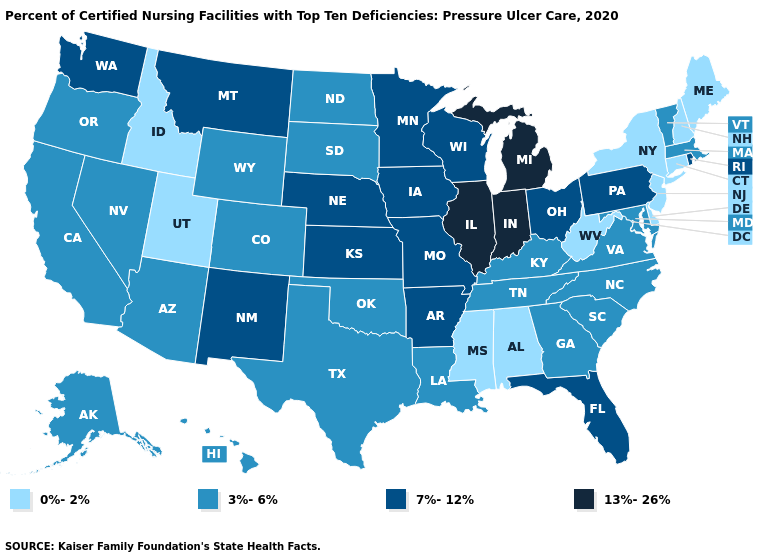Name the states that have a value in the range 7%-12%?
Give a very brief answer. Arkansas, Florida, Iowa, Kansas, Minnesota, Missouri, Montana, Nebraska, New Mexico, Ohio, Pennsylvania, Rhode Island, Washington, Wisconsin. How many symbols are there in the legend?
Concise answer only. 4. Name the states that have a value in the range 7%-12%?
Give a very brief answer. Arkansas, Florida, Iowa, Kansas, Minnesota, Missouri, Montana, Nebraska, New Mexico, Ohio, Pennsylvania, Rhode Island, Washington, Wisconsin. What is the value of Maine?
Write a very short answer. 0%-2%. What is the highest value in the West ?
Give a very brief answer. 7%-12%. What is the value of Georgia?
Concise answer only. 3%-6%. Name the states that have a value in the range 3%-6%?
Write a very short answer. Alaska, Arizona, California, Colorado, Georgia, Hawaii, Kentucky, Louisiana, Maryland, Massachusetts, Nevada, North Carolina, North Dakota, Oklahoma, Oregon, South Carolina, South Dakota, Tennessee, Texas, Vermont, Virginia, Wyoming. Which states hav the highest value in the Northeast?
Write a very short answer. Pennsylvania, Rhode Island. How many symbols are there in the legend?
Be succinct. 4. Does Minnesota have the highest value in the MidWest?
Give a very brief answer. No. How many symbols are there in the legend?
Quick response, please. 4. Does the first symbol in the legend represent the smallest category?
Be succinct. Yes. Name the states that have a value in the range 7%-12%?
Keep it brief. Arkansas, Florida, Iowa, Kansas, Minnesota, Missouri, Montana, Nebraska, New Mexico, Ohio, Pennsylvania, Rhode Island, Washington, Wisconsin. What is the value of Georgia?
Concise answer only. 3%-6%. What is the value of Virginia?
Write a very short answer. 3%-6%. 